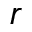Convert formula to latex. <formula><loc_0><loc_0><loc_500><loc_500>r</formula> 